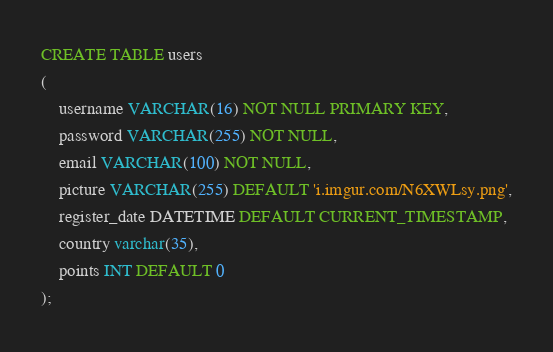Convert code to text. <code><loc_0><loc_0><loc_500><loc_500><_SQL_>CREATE TABLE users
(
	username VARCHAR(16) NOT NULL PRIMARY KEY,
	password VARCHAR(255) NOT NULL,
	email VARCHAR(100) NOT NULL,
	picture VARCHAR(255) DEFAULT 'i.imgur.com/N6XWLsy.png',
	register_date DATETIME DEFAULT CURRENT_TIMESTAMP,
	country varchar(35),
	points INT DEFAULT 0
);
</code> 